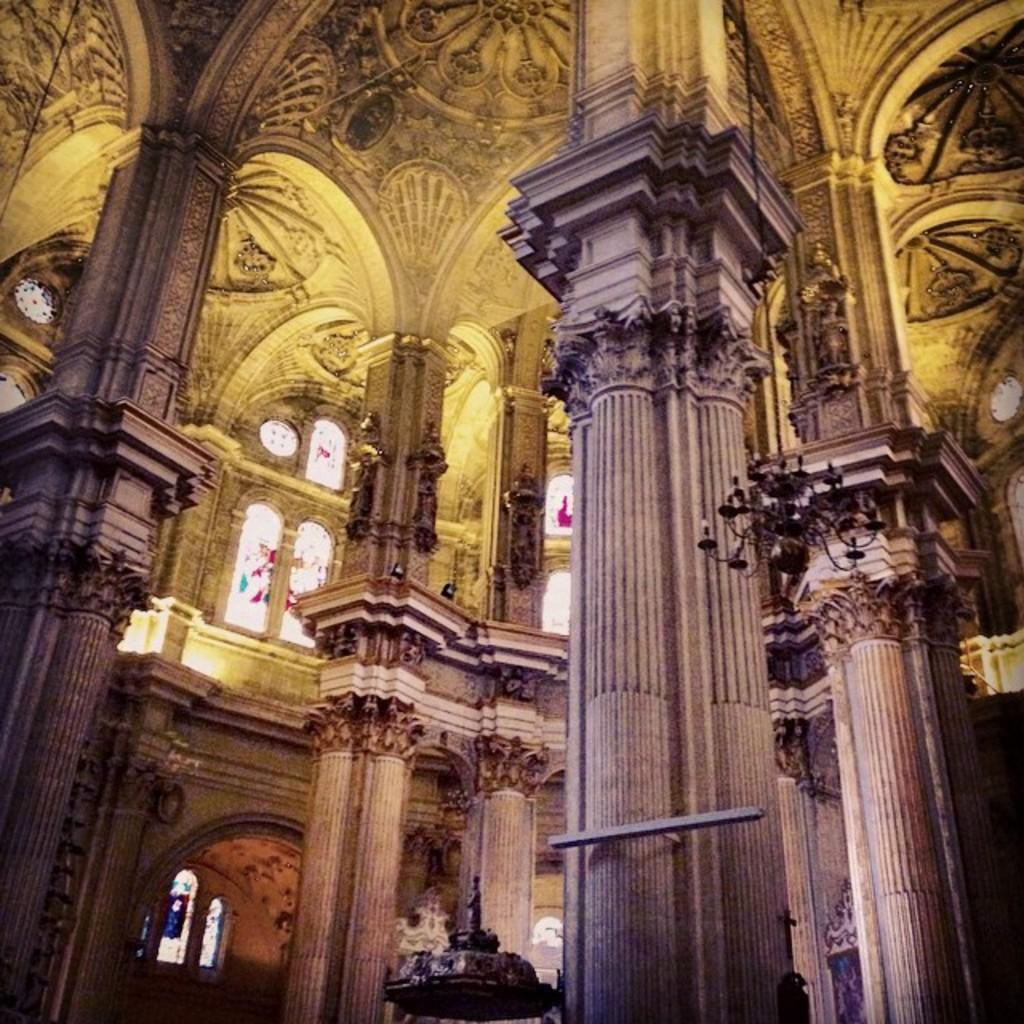What type of structure is shown in the image? The image depicts an inside part of a fort. What architectural feature can be seen in the image? There are glass windows in the image. What type of noise can be heard coming from the fort in the image? There is no indication of any noise in the image, as it only shows the inside part of a fort with glass windows. 